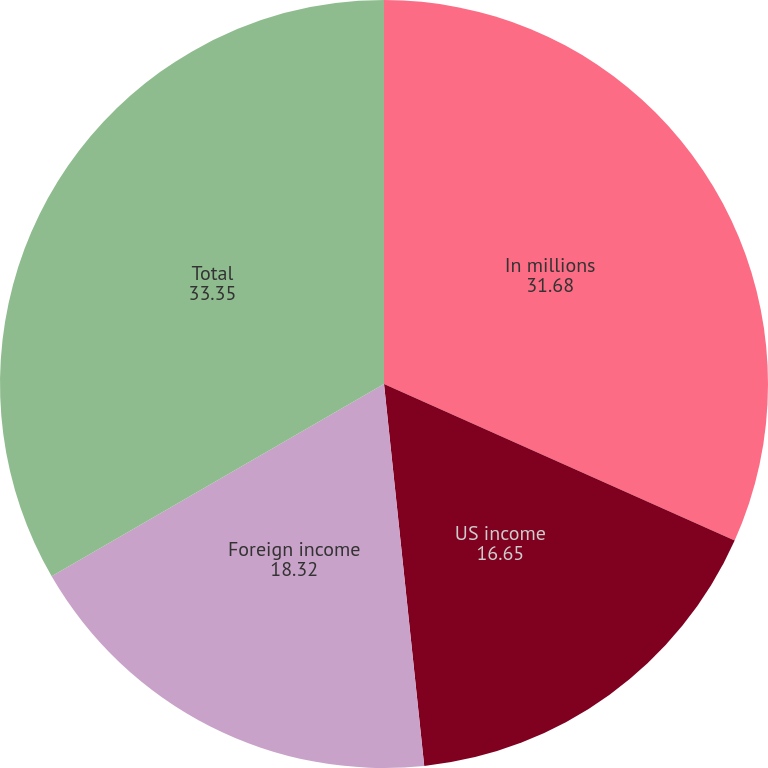<chart> <loc_0><loc_0><loc_500><loc_500><pie_chart><fcel>In millions<fcel>US income<fcel>Foreign income<fcel>Total<nl><fcel>31.68%<fcel>16.65%<fcel>18.32%<fcel>33.35%<nl></chart> 